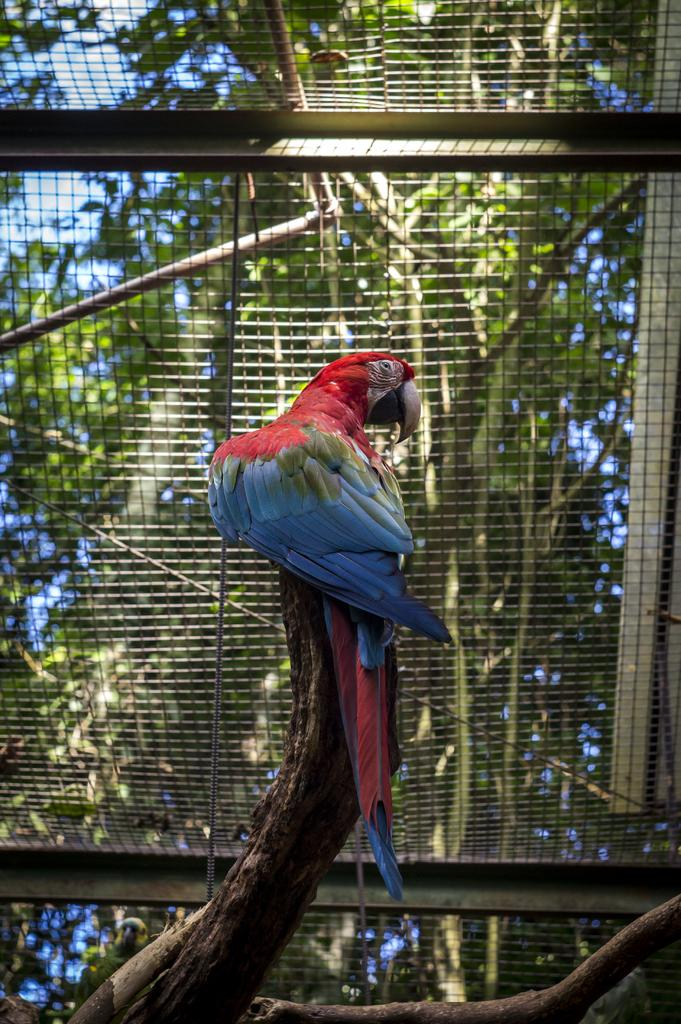What type of animal is in the image? There is a bird in the image. What colors can be seen on the bird? The bird has red and blue colors. What is at the bottom of the image? There is a stem at the bottom of the image. What can be seen in the background of the image? There is a fencing made of iron and trees visible in the background. How many chairs are placed under the roof in the image? There is no roof or chairs present in the image; it features a bird with a stem and a background with iron fencing and trees. 